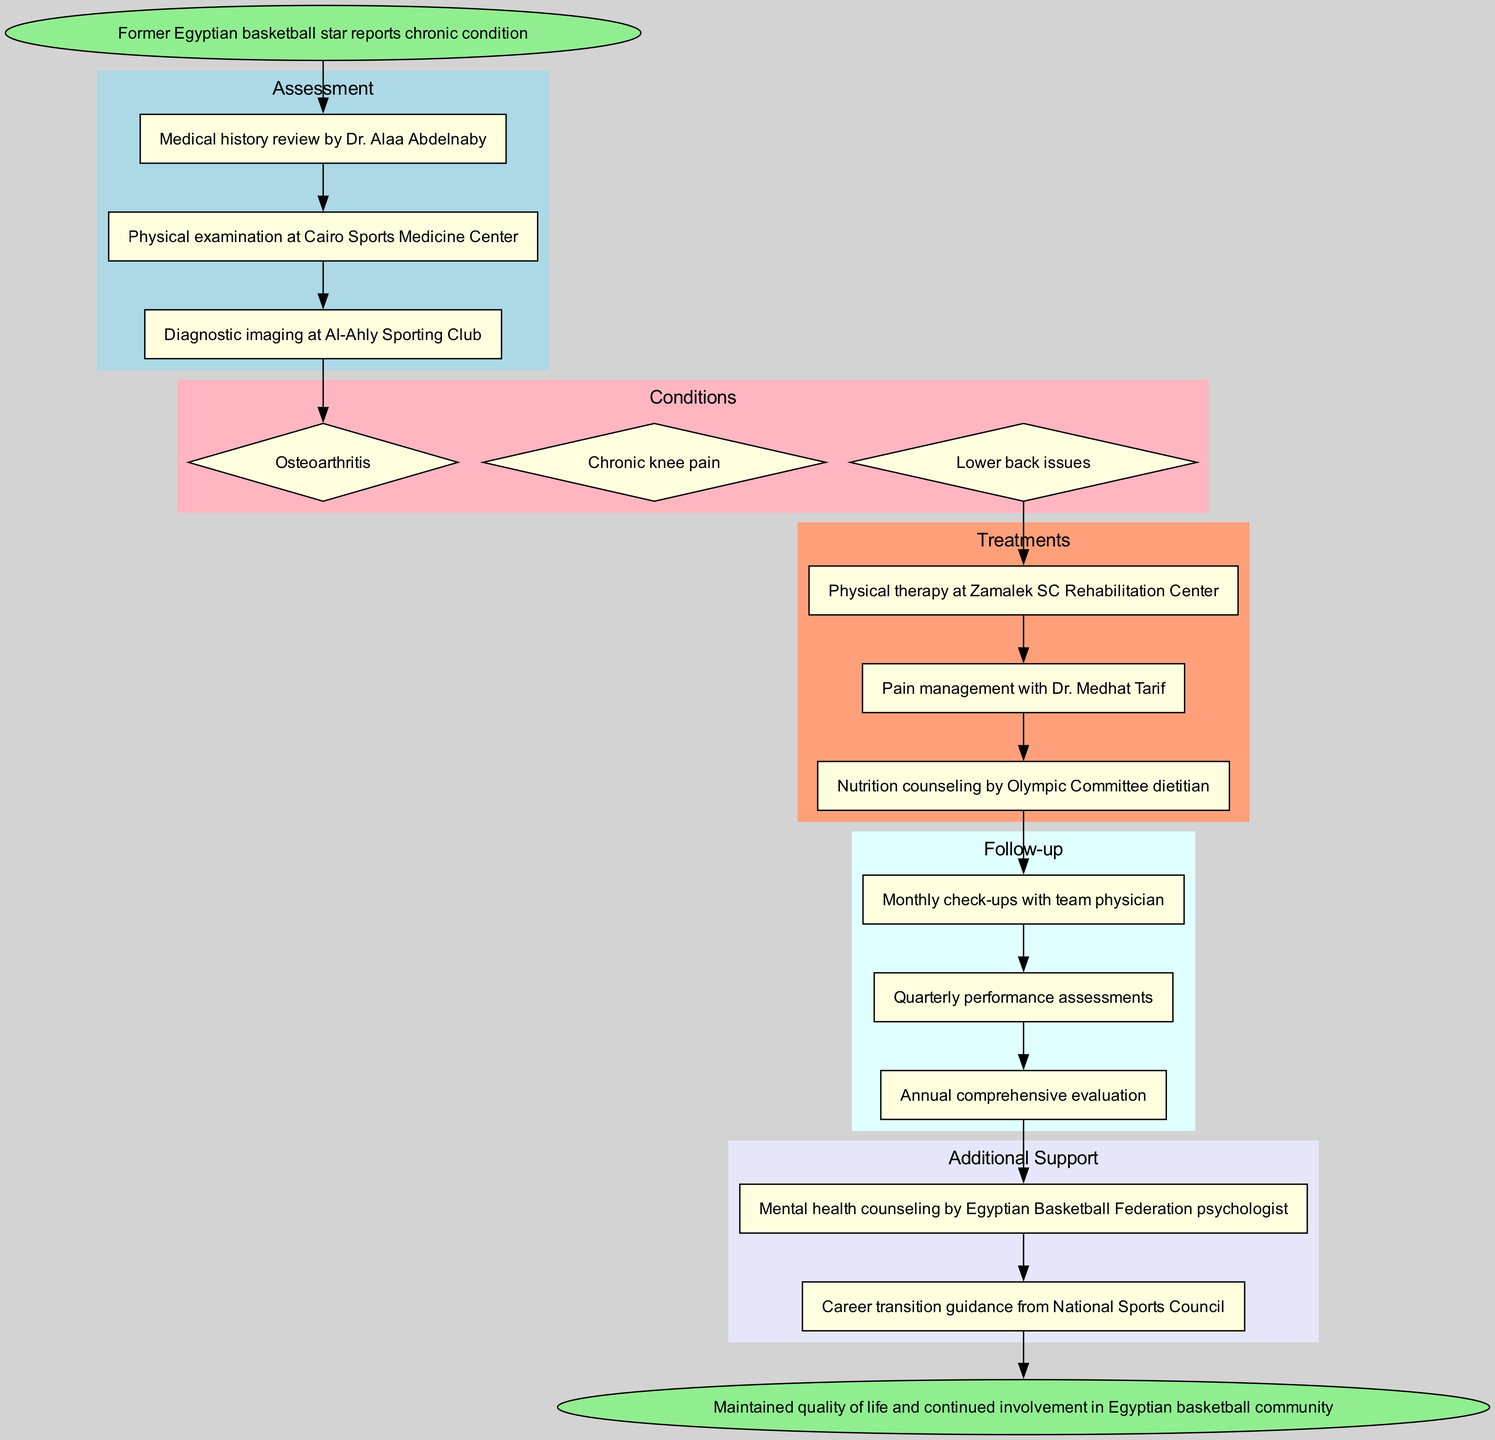What is the start point of the clinical pathway? The diagram begins with the 'Start' node, which clearly labels the start point of the clinical pathway, stating "Former Egyptian basketball star reports chronic condition."
Answer: Former Egyptian basketball star reports chronic condition How many assessment steps are there? By reviewing the subgraph labeled 'Assessment,' we can count the nodes representing the steps, which are three in total: medical history review, physical examination, and diagnostic imaging.
Answer: 3 What condition is linked to the third assessment step? Following the diagram from the assessment steps, the third assessment step is 'Diagnostic imaging at Al-Ahly Sporting Club,' which is directly connected to the first condition node labeled 'Osteoarthritis.'
Answer: Osteoarthritis Which treatment is last in the sequence? In the 'Treatments' subgraph, the last treatment node after counting is 'Nutrition counseling by Olympic Committee dietitian,' appearing last in the sequence of treatments available.
Answer: Nutrition counseling by Olympic Committee dietitian What type of counseling is provided as additional support? When examining the 'Additional Support' subgraph, one type of support provided is 'Mental health counseling by Egyptian Basketball Federation psychologist,' indicating the focus of that specific support.
Answer: Mental health counseling by Egyptian Basketball Federation psychologist What is the end point of the pathway? The final node in the diagram, labeled 'End,' contains the endpoint, which outlines the overall goal of the clinical pathway—maintaining quality of life and continued involvement.
Answer: Maintained quality of life and continued involvement in Egyptian basketball community How often will the follow-up check-ups occur? In the 'Follow-up' subgraph, the first node indicates that check-ups are scheduled on a monthly basis, specifying the frequency of follow-up visits.
Answer: Monthly check-ups From which center is the physical therapy provided? Following the treatment pathway, the specific treatment labeled 'Physical therapy at Zamalek SC Rehabilitation Center' identifies the location where physical therapy is administered.
Answer: Zamalek SC Rehabilitation Center Which professional will conduct the monthly check-ups? Reviewing the 'Follow-up' subgraph, it states that the team physician is responsible for conducting the monthly check-ups, identifying who oversees these evaluations.
Answer: Team physician 